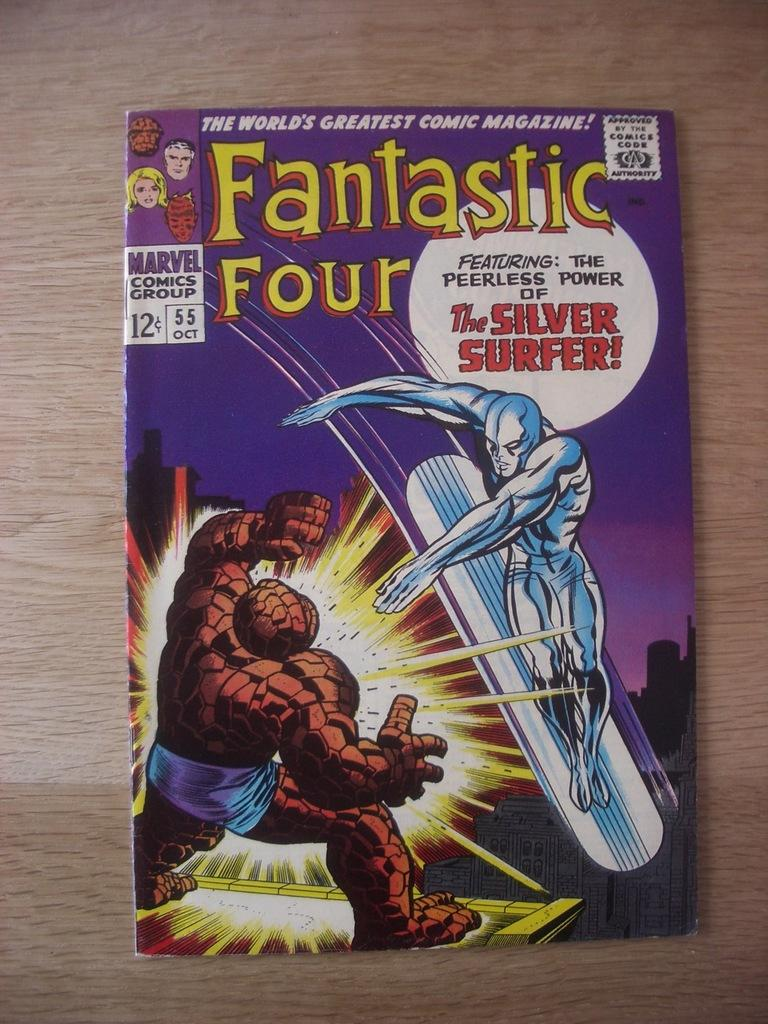<image>
Give a short and clear explanation of the subsequent image. A Fantastic Four Comic book features the Silver Surfer 